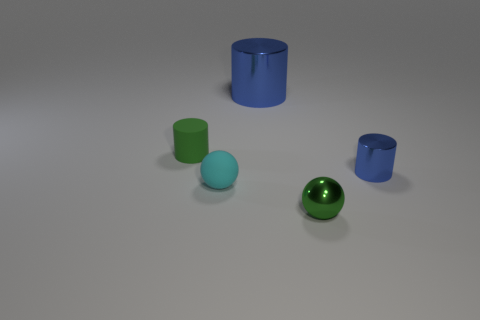What shape is the matte object in front of the small cylinder that is to the right of the big blue shiny object?
Offer a terse response. Sphere. Are there any other things that are the same color as the small matte ball?
Make the answer very short. No. What number of objects are either tiny brown spheres or large objects?
Your answer should be compact. 1. Is there a cyan ball that has the same size as the green matte object?
Offer a very short reply. Yes. The large blue metallic thing is what shape?
Offer a very short reply. Cylinder. Are there more blue metallic objects in front of the tiny matte cylinder than large blue metallic cylinders that are behind the big thing?
Ensure brevity in your answer.  Yes. Does the tiny ball that is to the right of the large blue object have the same color as the small cylinder that is to the right of the small cyan rubber thing?
Give a very brief answer. No. What is the shape of the cyan thing that is the same size as the green metallic thing?
Ensure brevity in your answer.  Sphere. Is there another metal thing that has the same shape as the green metallic object?
Offer a terse response. No. Does the small green thing that is left of the green metal ball have the same material as the blue object in front of the big metallic thing?
Offer a terse response. No. 